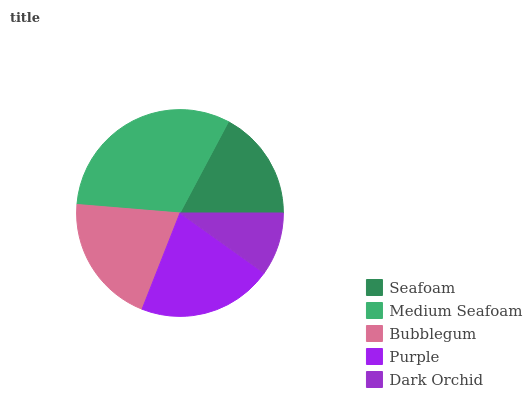Is Dark Orchid the minimum?
Answer yes or no. Yes. Is Medium Seafoam the maximum?
Answer yes or no. Yes. Is Bubblegum the minimum?
Answer yes or no. No. Is Bubblegum the maximum?
Answer yes or no. No. Is Medium Seafoam greater than Bubblegum?
Answer yes or no. Yes. Is Bubblegum less than Medium Seafoam?
Answer yes or no. Yes. Is Bubblegum greater than Medium Seafoam?
Answer yes or no. No. Is Medium Seafoam less than Bubblegum?
Answer yes or no. No. Is Bubblegum the high median?
Answer yes or no. Yes. Is Bubblegum the low median?
Answer yes or no. Yes. Is Seafoam the high median?
Answer yes or no. No. Is Seafoam the low median?
Answer yes or no. No. 